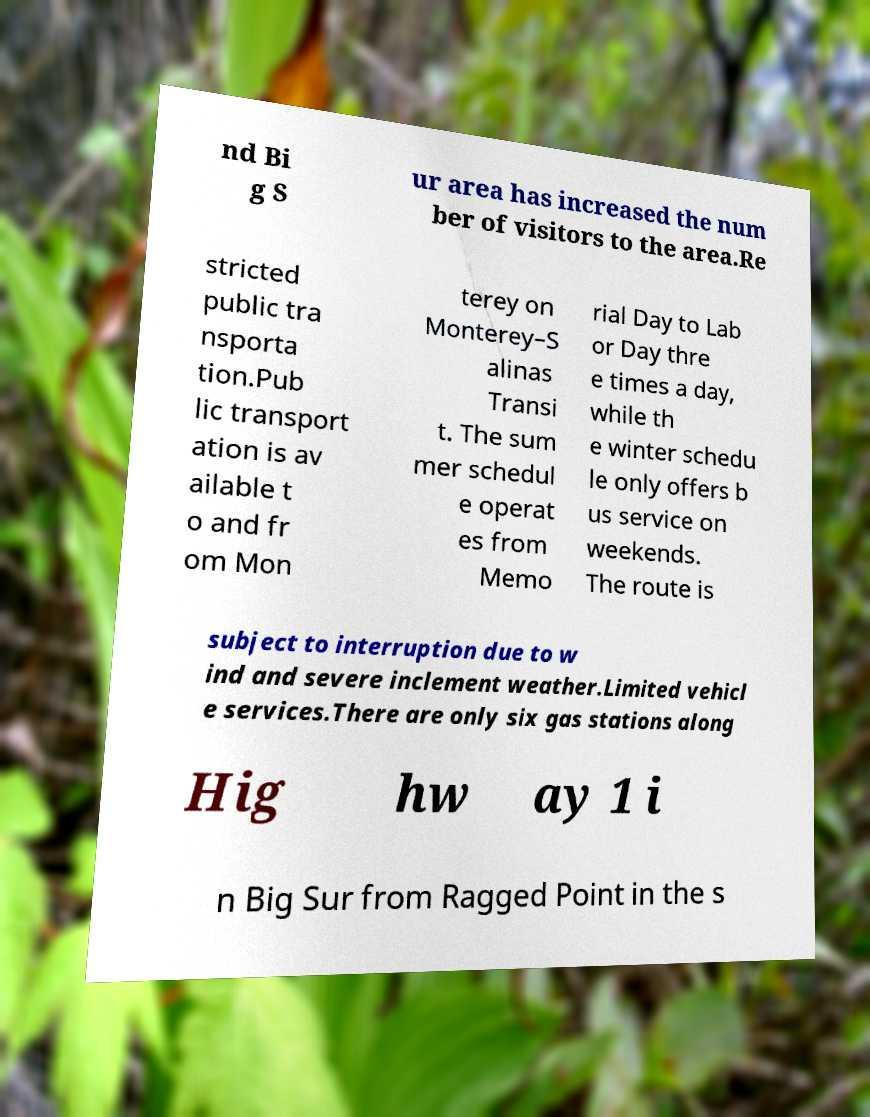Could you assist in decoding the text presented in this image and type it out clearly? nd Bi g S ur area has increased the num ber of visitors to the area.Re stricted public tra nsporta tion.Pub lic transport ation is av ailable t o and fr om Mon terey on Monterey–S alinas Transi t. The sum mer schedul e operat es from Memo rial Day to Lab or Day thre e times a day, while th e winter schedu le only offers b us service on weekends. The route is subject to interruption due to w ind and severe inclement weather.Limited vehicl e services.There are only six gas stations along Hig hw ay 1 i n Big Sur from Ragged Point in the s 